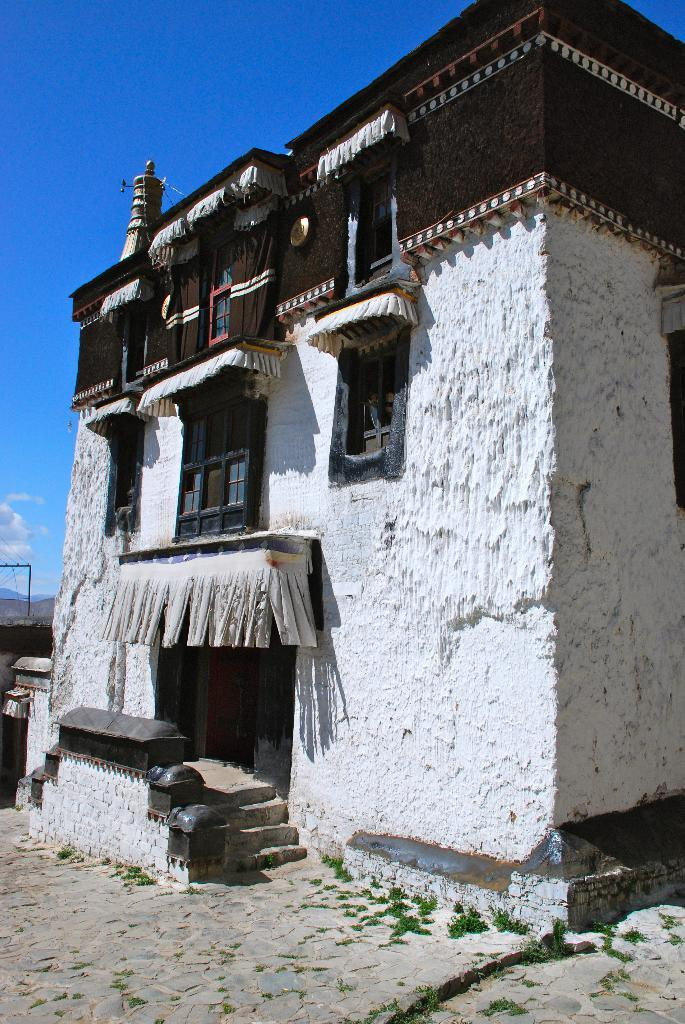What structure is the main subject of the image? There is a building in the image. What is hanging from the windows and doors of the building? Clothes are hanging from the windows and doors of the building. What can be seen in the background of the image? The sky is visible in the image. How would you describe the sky in the image? The sky is blue and cloudy. What type of fuel is being used by the army in the image? There is no army or fuel present in the image; it features a building with clothes hanging from its windows and doors, and a blue, cloudy sky. 